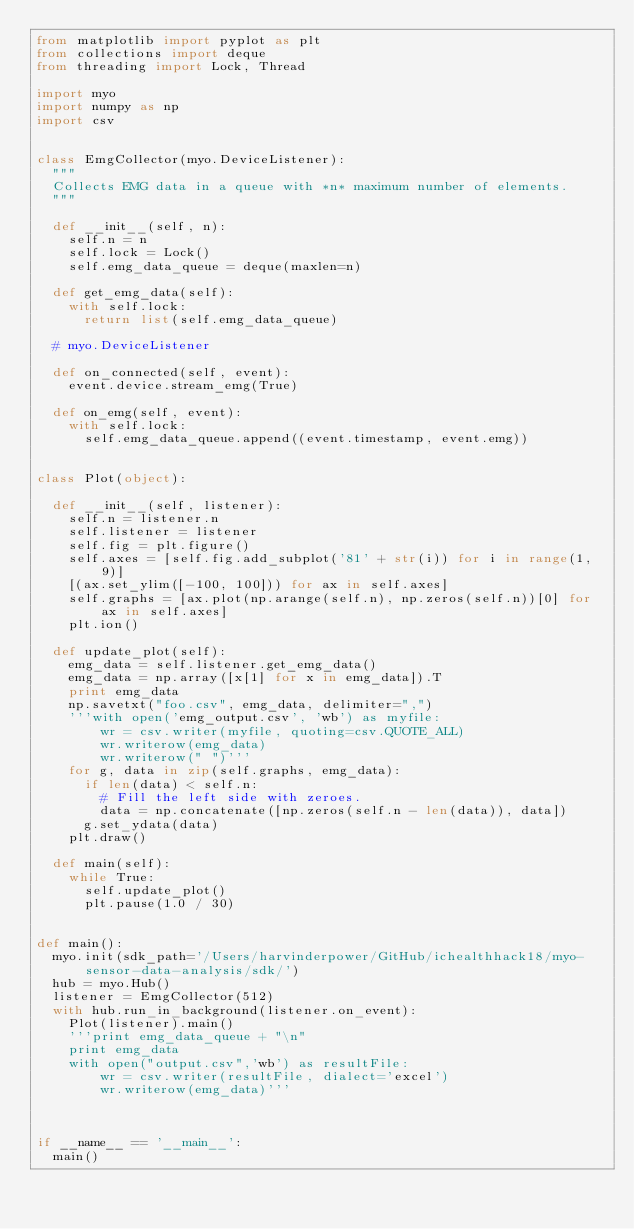Convert code to text. <code><loc_0><loc_0><loc_500><loc_500><_Python_>from matplotlib import pyplot as plt
from collections import deque
from threading import Lock, Thread

import myo
import numpy as np
import csv


class EmgCollector(myo.DeviceListener):
  """
  Collects EMG data in a queue with *n* maximum number of elements.
  """

  def __init__(self, n):
    self.n = n
    self.lock = Lock()
    self.emg_data_queue = deque(maxlen=n)

  def get_emg_data(self):
    with self.lock:
      return list(self.emg_data_queue)

  # myo.DeviceListener

  def on_connected(self, event):
    event.device.stream_emg(True)

  def on_emg(self, event):
    with self.lock:
      self.emg_data_queue.append((event.timestamp, event.emg))


class Plot(object):

  def __init__(self, listener):
    self.n = listener.n
    self.listener = listener
    self.fig = plt.figure()
    self.axes = [self.fig.add_subplot('81' + str(i)) for i in range(1, 9)]
    [(ax.set_ylim([-100, 100])) for ax in self.axes]
    self.graphs = [ax.plot(np.arange(self.n), np.zeros(self.n))[0] for ax in self.axes]
    plt.ion()

  def update_plot(self):
    emg_data = self.listener.get_emg_data()
    emg_data = np.array([x[1] for x in emg_data]).T
    print emg_data
    np.savetxt("foo.csv", emg_data, delimiter=",")
    '''with open('emg_output.csv', 'wb') as myfile:
        wr = csv.writer(myfile, quoting=csv.QUOTE_ALL)
        wr.writerow(emg_data)
        wr.writerow(" ")'''
    for g, data in zip(self.graphs, emg_data):
      if len(data) < self.n:
        # Fill the left side with zeroes.
        data = np.concatenate([np.zeros(self.n - len(data)), data])
      g.set_ydata(data)
    plt.draw()

  def main(self):
    while True:
      self.update_plot()
      plt.pause(1.0 / 30)


def main():
  myo.init(sdk_path='/Users/harvinderpower/GitHub/ichealthhack18/myo-sensor-data-analysis/sdk/')
  hub = myo.Hub()
  listener = EmgCollector(512)
  with hub.run_in_background(listener.on_event):
    Plot(listener).main()
    '''print emg_data_queue + "\n"
    print emg_data
    with open("output.csv",'wb') as resultFile:
        wr = csv.writer(resultFile, dialect='excel')
        wr.writerow(emg_data)'''



if __name__ == '__main__':
  main()
</code> 